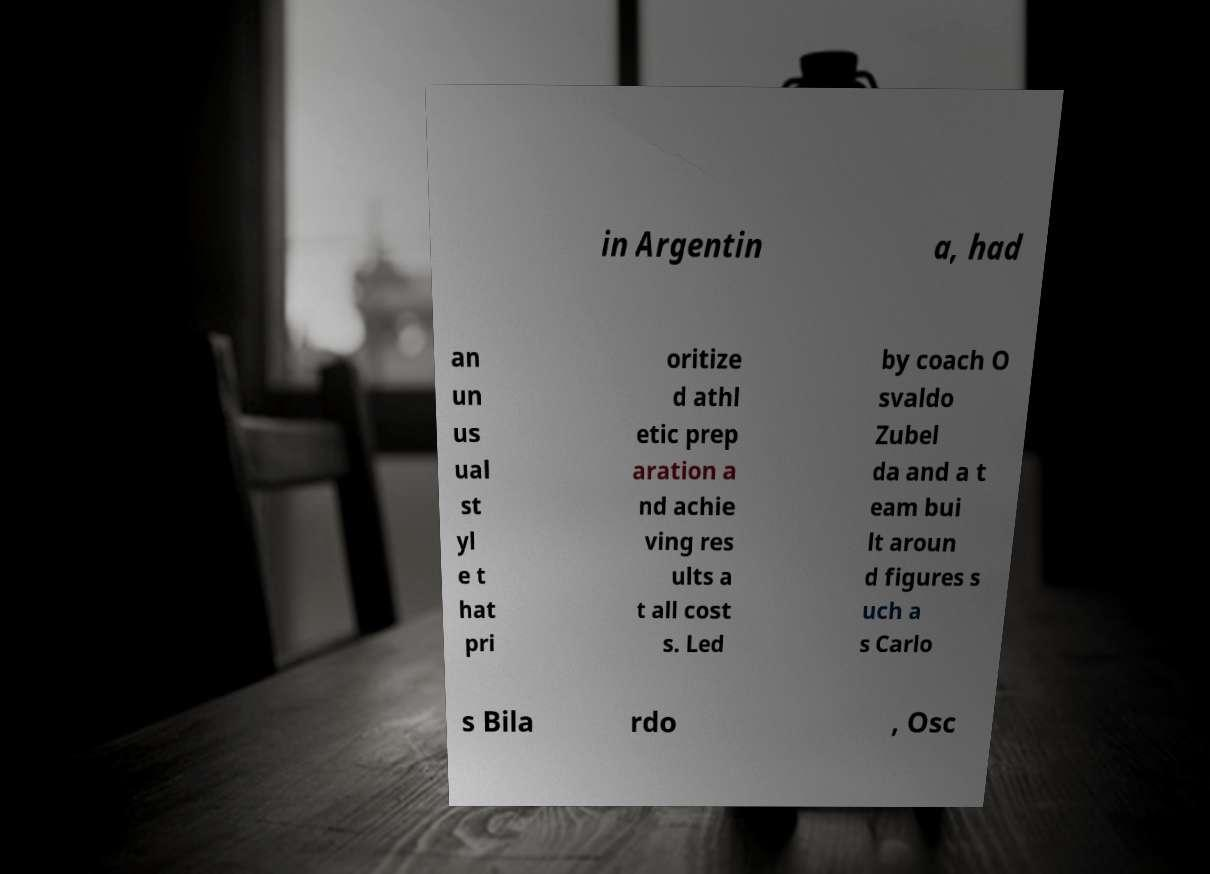I need the written content from this picture converted into text. Can you do that? in Argentin a, had an un us ual st yl e t hat pri oritize d athl etic prep aration a nd achie ving res ults a t all cost s. Led by coach O svaldo Zubel da and a t eam bui lt aroun d figures s uch a s Carlo s Bila rdo , Osc 